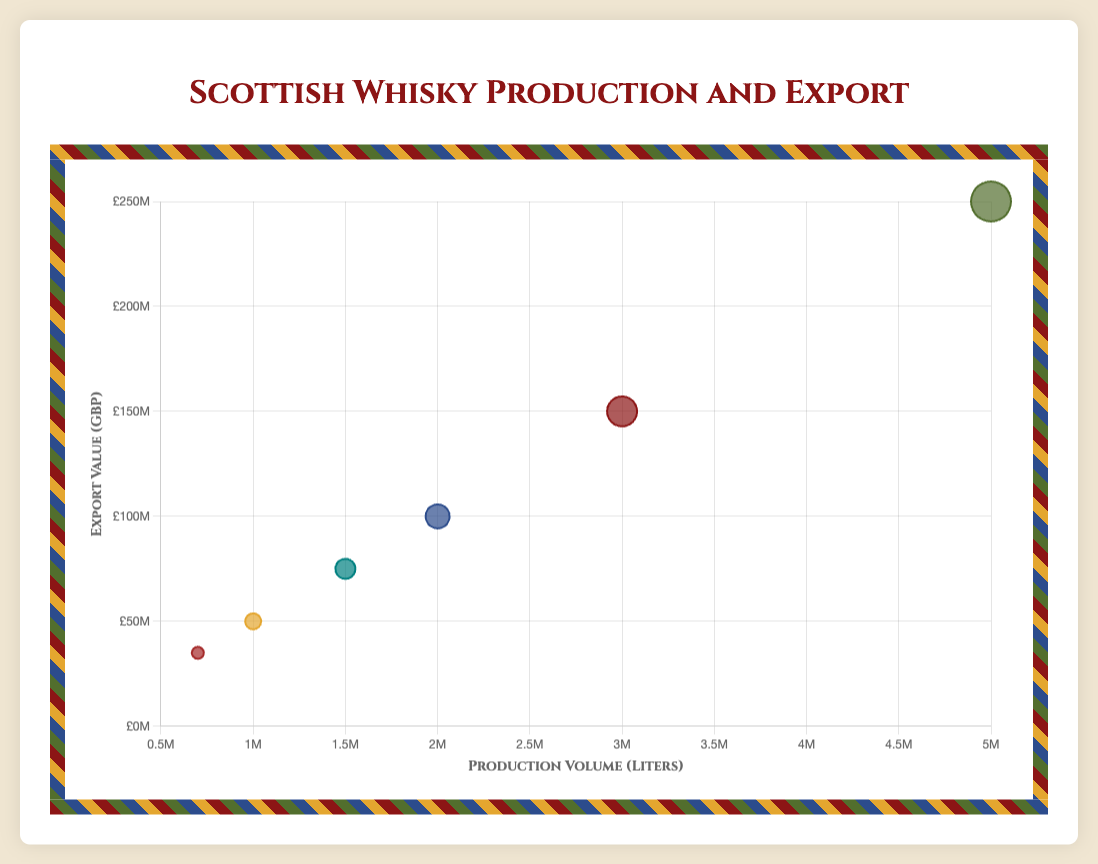What are the bubble colors used in the chart? The chart uses different colors for each region to differentiate them visually. These colors are maroon for Highlands, green for Speyside, blue for Islay, mustard for Lowlands, brown for Campbeltown, and teal for Islands.
Answer: Maroon, green, blue, mustard, brown, teal Which region has the highest whisky production volume? To find the region with the highest whisky production volume, look at the x-axis. The furthest point on the right represents Speyside with 5,000,000 liters.
Answer: Speyside What is the export value of the Islands region? Find the bubble labeled "Islands" and check its position on the y-axis. The bubble for Islands is at £75,000,000.
Answer: £75,000,000 Which region has both the smallest production volume and export value? The smallest bubble, representing Campbeltown, is located at the lowest end of both x-axis and y-axis, indicating the smallest production volume (700,000 liters) and export value (£35,000,000).
Answer: Campbeltown How much higher is the export value of Speyside compared to Islay? Find the bubbles for Speyside and Islay and read their y-axis values. Speyside is at £250,000,000, and Islay is at £100,000,000. Calculate the difference: £250,000,000 - £100,000,000 = £150,000,000.
Answer: £150,000,000 Order the regions by production volume from highest to lowest. Look at the x-axis positions of the bubbles. Order them from right to left: Speyside (5,000,000 liters), Highlands (3,000,000 liters), Islay (2,000,000 liters), Islands (1,500,000 liters), Lowlands (1,000,000 liters), Campbeltown (700,000 liters).
Answer: Speyside, Highlands, Islay, Islands, Lowlands, Campbeltown Which region does the largest bubble represent and what does it signify? The largest bubble is Speyside with a radius of 20, representing the highest production volume and export value among all regions.
Answer: Speyside Compare the export values of Highlands and Lowlands regions. Which one has a higher export value and by how much? Find the y-axis values for Highlands and Lowlands. Highlands is at £150,000,000 and Lowlands at £50,000,000. Calculate the difference: £150,000,000 - £50,000,000 = £100,000,000.
Answer: Highlands by £100,000,000 If the production volumes of Highlands and Islay are combined, what would be their total export value? Highlands' production volume is 3,000,000 liters and Islay's is 2,000,000 liters. Their combined volume is 5,000,000 liters, but the question asks for total export value. Add their y-axis values: £150,000,000 + £100,000,000 = £250,000,000.
Answer: £250,000,000 What percentage of total export value does the Speyside region contribute if the total export value of all regions is calculated? First, sum the export values: £150,000,000 (Highlands) + £250,000,000 (Speyside) + £100,000,000 (Islay) + £50,000,000 (Lowlands) + £35,000,000 (Campbeltown) + £75,000,000 (Islands) = £660,000,000. Then, calculate Speyside's contribution: (£250,000,000 / £660,000,000) * 100 = approx. 37.88%.
Answer: 37.88% 